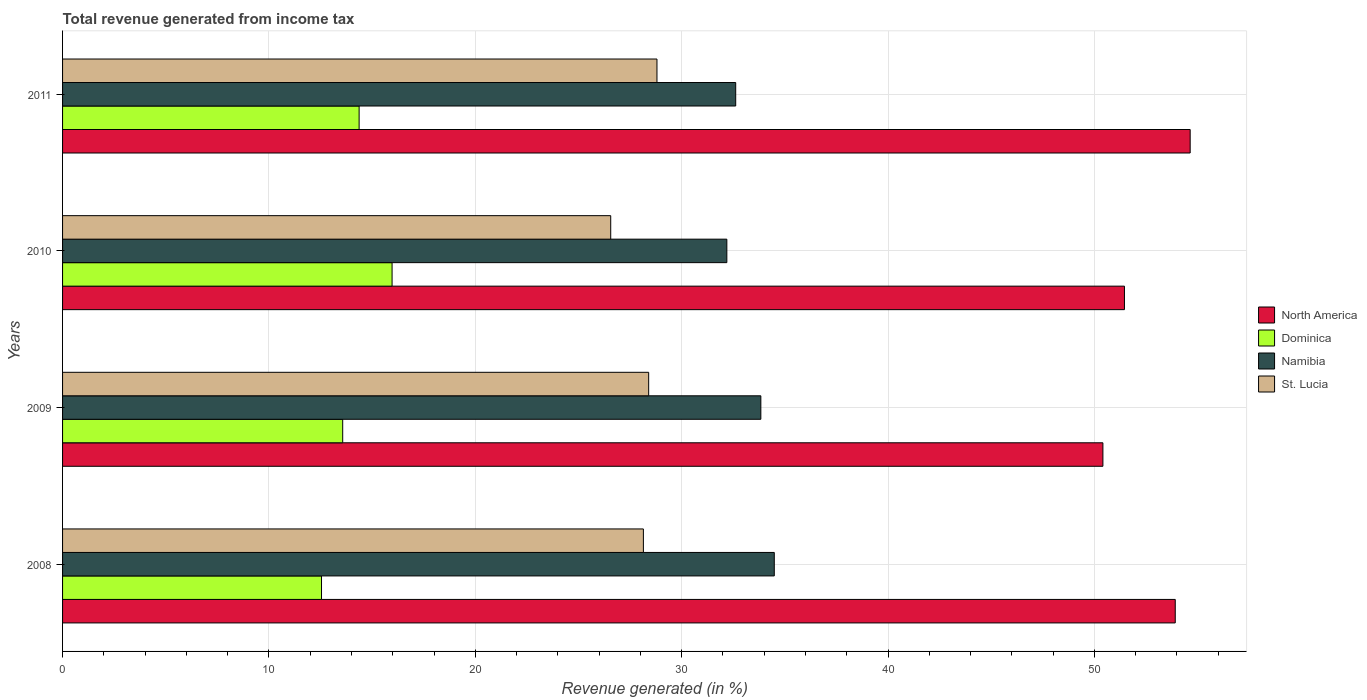What is the total revenue generated in St. Lucia in 2011?
Your answer should be very brief. 28.8. Across all years, what is the maximum total revenue generated in Dominica?
Your answer should be compact. 15.97. Across all years, what is the minimum total revenue generated in Dominica?
Provide a short and direct response. 12.55. In which year was the total revenue generated in Dominica maximum?
Your answer should be compact. 2010. What is the total total revenue generated in Dominica in the graph?
Your response must be concise. 56.46. What is the difference between the total revenue generated in Dominica in 2009 and that in 2011?
Offer a terse response. -0.8. What is the difference between the total revenue generated in St. Lucia in 2011 and the total revenue generated in Dominica in 2008?
Provide a short and direct response. 16.25. What is the average total revenue generated in Dominica per year?
Provide a succinct answer. 14.12. In the year 2008, what is the difference between the total revenue generated in North America and total revenue generated in St. Lucia?
Ensure brevity in your answer.  25.77. In how many years, is the total revenue generated in North America greater than 24 %?
Your answer should be very brief. 4. What is the ratio of the total revenue generated in Dominica in 2009 to that in 2010?
Make the answer very short. 0.85. What is the difference between the highest and the second highest total revenue generated in St. Lucia?
Offer a terse response. 0.4. What is the difference between the highest and the lowest total revenue generated in Dominica?
Offer a very short reply. 3.42. In how many years, is the total revenue generated in Namibia greater than the average total revenue generated in Namibia taken over all years?
Provide a short and direct response. 2. Is it the case that in every year, the sum of the total revenue generated in St. Lucia and total revenue generated in North America is greater than the sum of total revenue generated in Namibia and total revenue generated in Dominica?
Provide a succinct answer. Yes. What does the 3rd bar from the top in 2008 represents?
Your response must be concise. Dominica. What does the 1st bar from the bottom in 2011 represents?
Give a very brief answer. North America. Is it the case that in every year, the sum of the total revenue generated in St. Lucia and total revenue generated in Dominica is greater than the total revenue generated in North America?
Offer a terse response. No. How many bars are there?
Keep it short and to the point. 16. Are the values on the major ticks of X-axis written in scientific E-notation?
Your response must be concise. No. Does the graph contain any zero values?
Ensure brevity in your answer.  No. Does the graph contain grids?
Your response must be concise. Yes. Where does the legend appear in the graph?
Provide a succinct answer. Center right. How many legend labels are there?
Your answer should be compact. 4. What is the title of the graph?
Provide a succinct answer. Total revenue generated from income tax. What is the label or title of the X-axis?
Your answer should be compact. Revenue generated (in %). What is the label or title of the Y-axis?
Your answer should be compact. Years. What is the Revenue generated (in %) of North America in 2008?
Keep it short and to the point. 53.92. What is the Revenue generated (in %) of Dominica in 2008?
Keep it short and to the point. 12.55. What is the Revenue generated (in %) of Namibia in 2008?
Your answer should be very brief. 34.49. What is the Revenue generated (in %) of St. Lucia in 2008?
Offer a very short reply. 28.15. What is the Revenue generated (in %) in North America in 2009?
Ensure brevity in your answer.  50.41. What is the Revenue generated (in %) in Dominica in 2009?
Give a very brief answer. 13.57. What is the Revenue generated (in %) of Namibia in 2009?
Ensure brevity in your answer.  33.84. What is the Revenue generated (in %) of St. Lucia in 2009?
Your answer should be compact. 28.4. What is the Revenue generated (in %) of North America in 2010?
Provide a succinct answer. 51.46. What is the Revenue generated (in %) of Dominica in 2010?
Keep it short and to the point. 15.97. What is the Revenue generated (in %) in Namibia in 2010?
Offer a terse response. 32.19. What is the Revenue generated (in %) of St. Lucia in 2010?
Provide a short and direct response. 26.56. What is the Revenue generated (in %) of North America in 2011?
Your answer should be compact. 54.64. What is the Revenue generated (in %) in Dominica in 2011?
Provide a short and direct response. 14.37. What is the Revenue generated (in %) in Namibia in 2011?
Your answer should be very brief. 32.62. What is the Revenue generated (in %) of St. Lucia in 2011?
Your answer should be very brief. 28.8. Across all years, what is the maximum Revenue generated (in %) in North America?
Your answer should be compact. 54.64. Across all years, what is the maximum Revenue generated (in %) in Dominica?
Give a very brief answer. 15.97. Across all years, what is the maximum Revenue generated (in %) of Namibia?
Your response must be concise. 34.49. Across all years, what is the maximum Revenue generated (in %) of St. Lucia?
Give a very brief answer. 28.8. Across all years, what is the minimum Revenue generated (in %) in North America?
Provide a short and direct response. 50.41. Across all years, what is the minimum Revenue generated (in %) of Dominica?
Ensure brevity in your answer.  12.55. Across all years, what is the minimum Revenue generated (in %) in Namibia?
Give a very brief answer. 32.19. Across all years, what is the minimum Revenue generated (in %) in St. Lucia?
Keep it short and to the point. 26.56. What is the total Revenue generated (in %) in North America in the graph?
Offer a terse response. 210.43. What is the total Revenue generated (in %) in Dominica in the graph?
Your answer should be compact. 56.46. What is the total Revenue generated (in %) of Namibia in the graph?
Give a very brief answer. 133.13. What is the total Revenue generated (in %) in St. Lucia in the graph?
Provide a succinct answer. 111.91. What is the difference between the Revenue generated (in %) in North America in 2008 and that in 2009?
Provide a short and direct response. 3.51. What is the difference between the Revenue generated (in %) of Dominica in 2008 and that in 2009?
Ensure brevity in your answer.  -1.03. What is the difference between the Revenue generated (in %) in Namibia in 2008 and that in 2009?
Provide a succinct answer. 0.65. What is the difference between the Revenue generated (in %) of St. Lucia in 2008 and that in 2009?
Ensure brevity in your answer.  -0.26. What is the difference between the Revenue generated (in %) in North America in 2008 and that in 2010?
Make the answer very short. 2.46. What is the difference between the Revenue generated (in %) in Dominica in 2008 and that in 2010?
Offer a terse response. -3.42. What is the difference between the Revenue generated (in %) in Namibia in 2008 and that in 2010?
Offer a very short reply. 2.3. What is the difference between the Revenue generated (in %) of St. Lucia in 2008 and that in 2010?
Your answer should be very brief. 1.58. What is the difference between the Revenue generated (in %) in North America in 2008 and that in 2011?
Keep it short and to the point. -0.72. What is the difference between the Revenue generated (in %) of Dominica in 2008 and that in 2011?
Provide a short and direct response. -1.82. What is the difference between the Revenue generated (in %) of Namibia in 2008 and that in 2011?
Your answer should be very brief. 1.87. What is the difference between the Revenue generated (in %) in St. Lucia in 2008 and that in 2011?
Your answer should be compact. -0.66. What is the difference between the Revenue generated (in %) of North America in 2009 and that in 2010?
Keep it short and to the point. -1.04. What is the difference between the Revenue generated (in %) of Dominica in 2009 and that in 2010?
Give a very brief answer. -2.39. What is the difference between the Revenue generated (in %) of Namibia in 2009 and that in 2010?
Offer a very short reply. 1.65. What is the difference between the Revenue generated (in %) of St. Lucia in 2009 and that in 2010?
Ensure brevity in your answer.  1.84. What is the difference between the Revenue generated (in %) in North America in 2009 and that in 2011?
Keep it short and to the point. -4.23. What is the difference between the Revenue generated (in %) of Dominica in 2009 and that in 2011?
Provide a succinct answer. -0.8. What is the difference between the Revenue generated (in %) of Namibia in 2009 and that in 2011?
Give a very brief answer. 1.22. What is the difference between the Revenue generated (in %) in St. Lucia in 2009 and that in 2011?
Make the answer very short. -0.4. What is the difference between the Revenue generated (in %) in North America in 2010 and that in 2011?
Your answer should be very brief. -3.18. What is the difference between the Revenue generated (in %) in Dominica in 2010 and that in 2011?
Offer a terse response. 1.6. What is the difference between the Revenue generated (in %) in Namibia in 2010 and that in 2011?
Give a very brief answer. -0.43. What is the difference between the Revenue generated (in %) of St. Lucia in 2010 and that in 2011?
Your answer should be compact. -2.24. What is the difference between the Revenue generated (in %) of North America in 2008 and the Revenue generated (in %) of Dominica in 2009?
Provide a short and direct response. 40.34. What is the difference between the Revenue generated (in %) of North America in 2008 and the Revenue generated (in %) of Namibia in 2009?
Your answer should be very brief. 20.08. What is the difference between the Revenue generated (in %) of North America in 2008 and the Revenue generated (in %) of St. Lucia in 2009?
Ensure brevity in your answer.  25.52. What is the difference between the Revenue generated (in %) of Dominica in 2008 and the Revenue generated (in %) of Namibia in 2009?
Offer a terse response. -21.29. What is the difference between the Revenue generated (in %) of Dominica in 2008 and the Revenue generated (in %) of St. Lucia in 2009?
Your answer should be very brief. -15.85. What is the difference between the Revenue generated (in %) of Namibia in 2008 and the Revenue generated (in %) of St. Lucia in 2009?
Make the answer very short. 6.09. What is the difference between the Revenue generated (in %) in North America in 2008 and the Revenue generated (in %) in Dominica in 2010?
Keep it short and to the point. 37.95. What is the difference between the Revenue generated (in %) in North America in 2008 and the Revenue generated (in %) in Namibia in 2010?
Offer a very short reply. 21.73. What is the difference between the Revenue generated (in %) of North America in 2008 and the Revenue generated (in %) of St. Lucia in 2010?
Keep it short and to the point. 27.36. What is the difference between the Revenue generated (in %) in Dominica in 2008 and the Revenue generated (in %) in Namibia in 2010?
Your response must be concise. -19.64. What is the difference between the Revenue generated (in %) in Dominica in 2008 and the Revenue generated (in %) in St. Lucia in 2010?
Your answer should be compact. -14.01. What is the difference between the Revenue generated (in %) of Namibia in 2008 and the Revenue generated (in %) of St. Lucia in 2010?
Give a very brief answer. 7.93. What is the difference between the Revenue generated (in %) in North America in 2008 and the Revenue generated (in %) in Dominica in 2011?
Your answer should be very brief. 39.55. What is the difference between the Revenue generated (in %) in North America in 2008 and the Revenue generated (in %) in Namibia in 2011?
Offer a terse response. 21.3. What is the difference between the Revenue generated (in %) of North America in 2008 and the Revenue generated (in %) of St. Lucia in 2011?
Provide a short and direct response. 25.11. What is the difference between the Revenue generated (in %) in Dominica in 2008 and the Revenue generated (in %) in Namibia in 2011?
Keep it short and to the point. -20.07. What is the difference between the Revenue generated (in %) of Dominica in 2008 and the Revenue generated (in %) of St. Lucia in 2011?
Your answer should be compact. -16.25. What is the difference between the Revenue generated (in %) in Namibia in 2008 and the Revenue generated (in %) in St. Lucia in 2011?
Offer a very short reply. 5.68. What is the difference between the Revenue generated (in %) of North America in 2009 and the Revenue generated (in %) of Dominica in 2010?
Provide a succinct answer. 34.44. What is the difference between the Revenue generated (in %) of North America in 2009 and the Revenue generated (in %) of Namibia in 2010?
Provide a short and direct response. 18.22. What is the difference between the Revenue generated (in %) in North America in 2009 and the Revenue generated (in %) in St. Lucia in 2010?
Provide a succinct answer. 23.85. What is the difference between the Revenue generated (in %) of Dominica in 2009 and the Revenue generated (in %) of Namibia in 2010?
Provide a succinct answer. -18.61. What is the difference between the Revenue generated (in %) of Dominica in 2009 and the Revenue generated (in %) of St. Lucia in 2010?
Provide a short and direct response. -12.99. What is the difference between the Revenue generated (in %) of Namibia in 2009 and the Revenue generated (in %) of St. Lucia in 2010?
Make the answer very short. 7.28. What is the difference between the Revenue generated (in %) in North America in 2009 and the Revenue generated (in %) in Dominica in 2011?
Make the answer very short. 36.04. What is the difference between the Revenue generated (in %) in North America in 2009 and the Revenue generated (in %) in Namibia in 2011?
Ensure brevity in your answer.  17.79. What is the difference between the Revenue generated (in %) in North America in 2009 and the Revenue generated (in %) in St. Lucia in 2011?
Keep it short and to the point. 21.61. What is the difference between the Revenue generated (in %) of Dominica in 2009 and the Revenue generated (in %) of Namibia in 2011?
Your response must be concise. -19.04. What is the difference between the Revenue generated (in %) in Dominica in 2009 and the Revenue generated (in %) in St. Lucia in 2011?
Your response must be concise. -15.23. What is the difference between the Revenue generated (in %) in Namibia in 2009 and the Revenue generated (in %) in St. Lucia in 2011?
Ensure brevity in your answer.  5.03. What is the difference between the Revenue generated (in %) in North America in 2010 and the Revenue generated (in %) in Dominica in 2011?
Keep it short and to the point. 37.09. What is the difference between the Revenue generated (in %) of North America in 2010 and the Revenue generated (in %) of Namibia in 2011?
Give a very brief answer. 18.84. What is the difference between the Revenue generated (in %) in North America in 2010 and the Revenue generated (in %) in St. Lucia in 2011?
Provide a succinct answer. 22.65. What is the difference between the Revenue generated (in %) in Dominica in 2010 and the Revenue generated (in %) in Namibia in 2011?
Offer a very short reply. -16.65. What is the difference between the Revenue generated (in %) of Dominica in 2010 and the Revenue generated (in %) of St. Lucia in 2011?
Provide a short and direct response. -12.84. What is the difference between the Revenue generated (in %) in Namibia in 2010 and the Revenue generated (in %) in St. Lucia in 2011?
Your response must be concise. 3.39. What is the average Revenue generated (in %) in North America per year?
Make the answer very short. 52.61. What is the average Revenue generated (in %) of Dominica per year?
Your response must be concise. 14.12. What is the average Revenue generated (in %) of Namibia per year?
Keep it short and to the point. 33.28. What is the average Revenue generated (in %) in St. Lucia per year?
Keep it short and to the point. 27.98. In the year 2008, what is the difference between the Revenue generated (in %) in North America and Revenue generated (in %) in Dominica?
Provide a short and direct response. 41.37. In the year 2008, what is the difference between the Revenue generated (in %) of North America and Revenue generated (in %) of Namibia?
Provide a short and direct response. 19.43. In the year 2008, what is the difference between the Revenue generated (in %) in North America and Revenue generated (in %) in St. Lucia?
Your response must be concise. 25.77. In the year 2008, what is the difference between the Revenue generated (in %) in Dominica and Revenue generated (in %) in Namibia?
Provide a short and direct response. -21.94. In the year 2008, what is the difference between the Revenue generated (in %) of Dominica and Revenue generated (in %) of St. Lucia?
Offer a very short reply. -15.6. In the year 2008, what is the difference between the Revenue generated (in %) of Namibia and Revenue generated (in %) of St. Lucia?
Provide a short and direct response. 6.34. In the year 2009, what is the difference between the Revenue generated (in %) of North America and Revenue generated (in %) of Dominica?
Your response must be concise. 36.84. In the year 2009, what is the difference between the Revenue generated (in %) of North America and Revenue generated (in %) of Namibia?
Keep it short and to the point. 16.58. In the year 2009, what is the difference between the Revenue generated (in %) of North America and Revenue generated (in %) of St. Lucia?
Your response must be concise. 22.01. In the year 2009, what is the difference between the Revenue generated (in %) in Dominica and Revenue generated (in %) in Namibia?
Ensure brevity in your answer.  -20.26. In the year 2009, what is the difference between the Revenue generated (in %) of Dominica and Revenue generated (in %) of St. Lucia?
Ensure brevity in your answer.  -14.83. In the year 2009, what is the difference between the Revenue generated (in %) of Namibia and Revenue generated (in %) of St. Lucia?
Give a very brief answer. 5.44. In the year 2010, what is the difference between the Revenue generated (in %) of North America and Revenue generated (in %) of Dominica?
Ensure brevity in your answer.  35.49. In the year 2010, what is the difference between the Revenue generated (in %) in North America and Revenue generated (in %) in Namibia?
Your answer should be very brief. 19.27. In the year 2010, what is the difference between the Revenue generated (in %) in North America and Revenue generated (in %) in St. Lucia?
Offer a very short reply. 24.89. In the year 2010, what is the difference between the Revenue generated (in %) of Dominica and Revenue generated (in %) of Namibia?
Provide a succinct answer. -16.22. In the year 2010, what is the difference between the Revenue generated (in %) in Dominica and Revenue generated (in %) in St. Lucia?
Provide a short and direct response. -10.59. In the year 2010, what is the difference between the Revenue generated (in %) in Namibia and Revenue generated (in %) in St. Lucia?
Keep it short and to the point. 5.63. In the year 2011, what is the difference between the Revenue generated (in %) of North America and Revenue generated (in %) of Dominica?
Your response must be concise. 40.27. In the year 2011, what is the difference between the Revenue generated (in %) of North America and Revenue generated (in %) of Namibia?
Provide a short and direct response. 22.02. In the year 2011, what is the difference between the Revenue generated (in %) of North America and Revenue generated (in %) of St. Lucia?
Provide a succinct answer. 25.84. In the year 2011, what is the difference between the Revenue generated (in %) in Dominica and Revenue generated (in %) in Namibia?
Provide a succinct answer. -18.25. In the year 2011, what is the difference between the Revenue generated (in %) in Dominica and Revenue generated (in %) in St. Lucia?
Ensure brevity in your answer.  -14.43. In the year 2011, what is the difference between the Revenue generated (in %) of Namibia and Revenue generated (in %) of St. Lucia?
Make the answer very short. 3.82. What is the ratio of the Revenue generated (in %) of North America in 2008 to that in 2009?
Provide a short and direct response. 1.07. What is the ratio of the Revenue generated (in %) in Dominica in 2008 to that in 2009?
Your answer should be compact. 0.92. What is the ratio of the Revenue generated (in %) in Namibia in 2008 to that in 2009?
Ensure brevity in your answer.  1.02. What is the ratio of the Revenue generated (in %) in St. Lucia in 2008 to that in 2009?
Offer a very short reply. 0.99. What is the ratio of the Revenue generated (in %) in North America in 2008 to that in 2010?
Give a very brief answer. 1.05. What is the ratio of the Revenue generated (in %) in Dominica in 2008 to that in 2010?
Ensure brevity in your answer.  0.79. What is the ratio of the Revenue generated (in %) in Namibia in 2008 to that in 2010?
Provide a succinct answer. 1.07. What is the ratio of the Revenue generated (in %) of St. Lucia in 2008 to that in 2010?
Give a very brief answer. 1.06. What is the ratio of the Revenue generated (in %) of North America in 2008 to that in 2011?
Make the answer very short. 0.99. What is the ratio of the Revenue generated (in %) of Dominica in 2008 to that in 2011?
Offer a terse response. 0.87. What is the ratio of the Revenue generated (in %) of Namibia in 2008 to that in 2011?
Offer a very short reply. 1.06. What is the ratio of the Revenue generated (in %) in St. Lucia in 2008 to that in 2011?
Give a very brief answer. 0.98. What is the ratio of the Revenue generated (in %) in North America in 2009 to that in 2010?
Your answer should be very brief. 0.98. What is the ratio of the Revenue generated (in %) in Dominica in 2009 to that in 2010?
Keep it short and to the point. 0.85. What is the ratio of the Revenue generated (in %) of Namibia in 2009 to that in 2010?
Offer a terse response. 1.05. What is the ratio of the Revenue generated (in %) of St. Lucia in 2009 to that in 2010?
Ensure brevity in your answer.  1.07. What is the ratio of the Revenue generated (in %) in North America in 2009 to that in 2011?
Keep it short and to the point. 0.92. What is the ratio of the Revenue generated (in %) of Dominica in 2009 to that in 2011?
Keep it short and to the point. 0.94. What is the ratio of the Revenue generated (in %) of Namibia in 2009 to that in 2011?
Ensure brevity in your answer.  1.04. What is the ratio of the Revenue generated (in %) of North America in 2010 to that in 2011?
Your answer should be very brief. 0.94. What is the ratio of the Revenue generated (in %) of Dominica in 2010 to that in 2011?
Your answer should be compact. 1.11. What is the ratio of the Revenue generated (in %) in St. Lucia in 2010 to that in 2011?
Your answer should be very brief. 0.92. What is the difference between the highest and the second highest Revenue generated (in %) in North America?
Your answer should be very brief. 0.72. What is the difference between the highest and the second highest Revenue generated (in %) in Dominica?
Provide a short and direct response. 1.6. What is the difference between the highest and the second highest Revenue generated (in %) in Namibia?
Your response must be concise. 0.65. What is the difference between the highest and the second highest Revenue generated (in %) in St. Lucia?
Offer a very short reply. 0.4. What is the difference between the highest and the lowest Revenue generated (in %) of North America?
Provide a short and direct response. 4.23. What is the difference between the highest and the lowest Revenue generated (in %) of Dominica?
Offer a very short reply. 3.42. What is the difference between the highest and the lowest Revenue generated (in %) of Namibia?
Give a very brief answer. 2.3. What is the difference between the highest and the lowest Revenue generated (in %) of St. Lucia?
Ensure brevity in your answer.  2.24. 